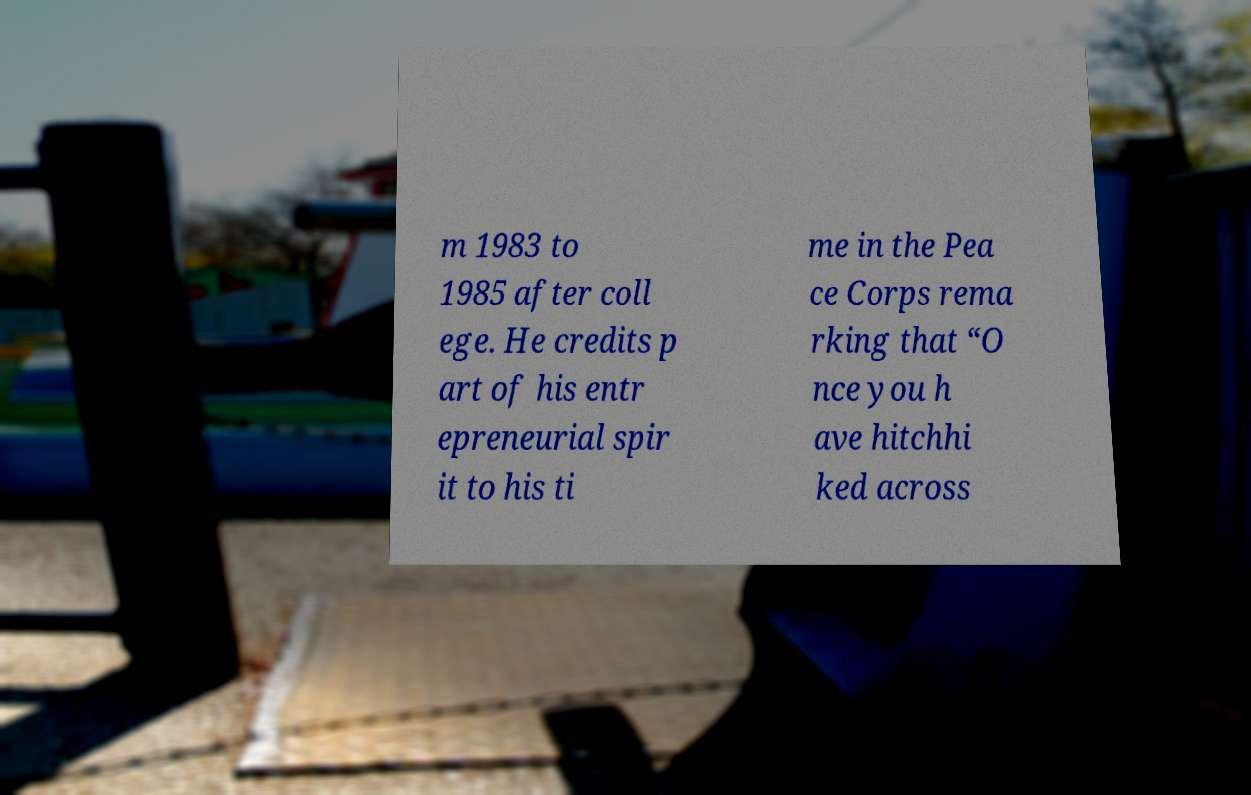Can you read and provide the text displayed in the image?This photo seems to have some interesting text. Can you extract and type it out for me? m 1983 to 1985 after coll ege. He credits p art of his entr epreneurial spir it to his ti me in the Pea ce Corps rema rking that “O nce you h ave hitchhi ked across 